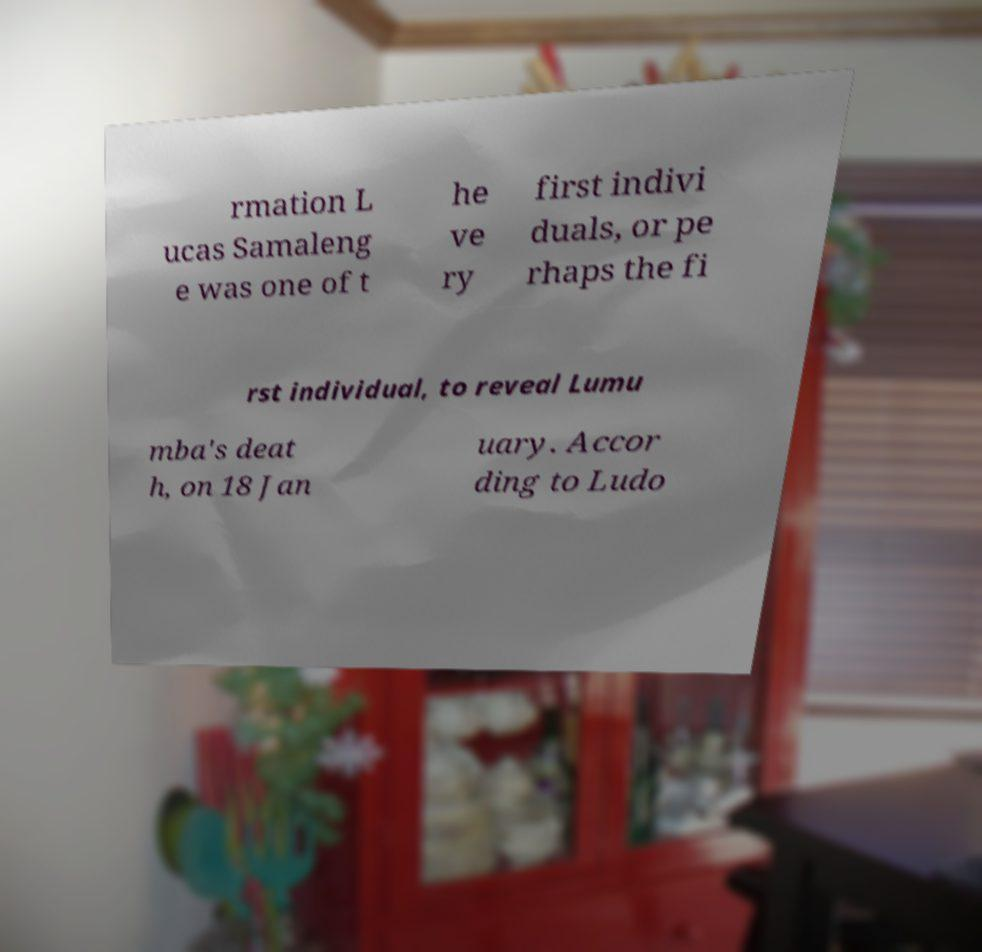Please identify and transcribe the text found in this image. rmation L ucas Samaleng e was one of t he ve ry first indivi duals, or pe rhaps the fi rst individual, to reveal Lumu mba's deat h, on 18 Jan uary. Accor ding to Ludo 